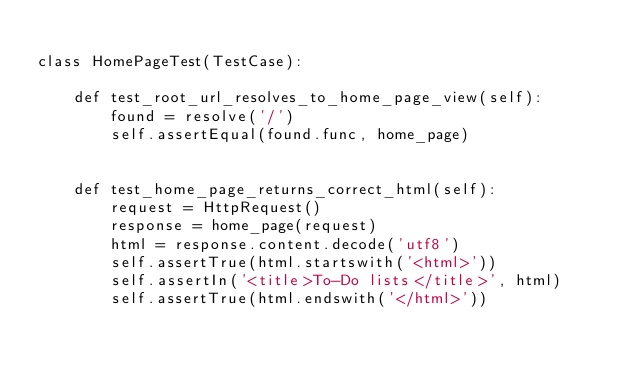<code> <loc_0><loc_0><loc_500><loc_500><_Python_>
class HomePageTest(TestCase):

    def test_root_url_resolves_to_home_page_view(self):
        found = resolve('/')
        self.assertEqual(found.func, home_page)


    def test_home_page_returns_correct_html(self):
        request = HttpRequest()
        response = home_page(request)
        html = response.content.decode('utf8')
        self.assertTrue(html.startswith('<html>'))
        self.assertIn('<title>To-Do lists</title>', html)
        self.assertTrue(html.endswith('</html>'))
</code> 